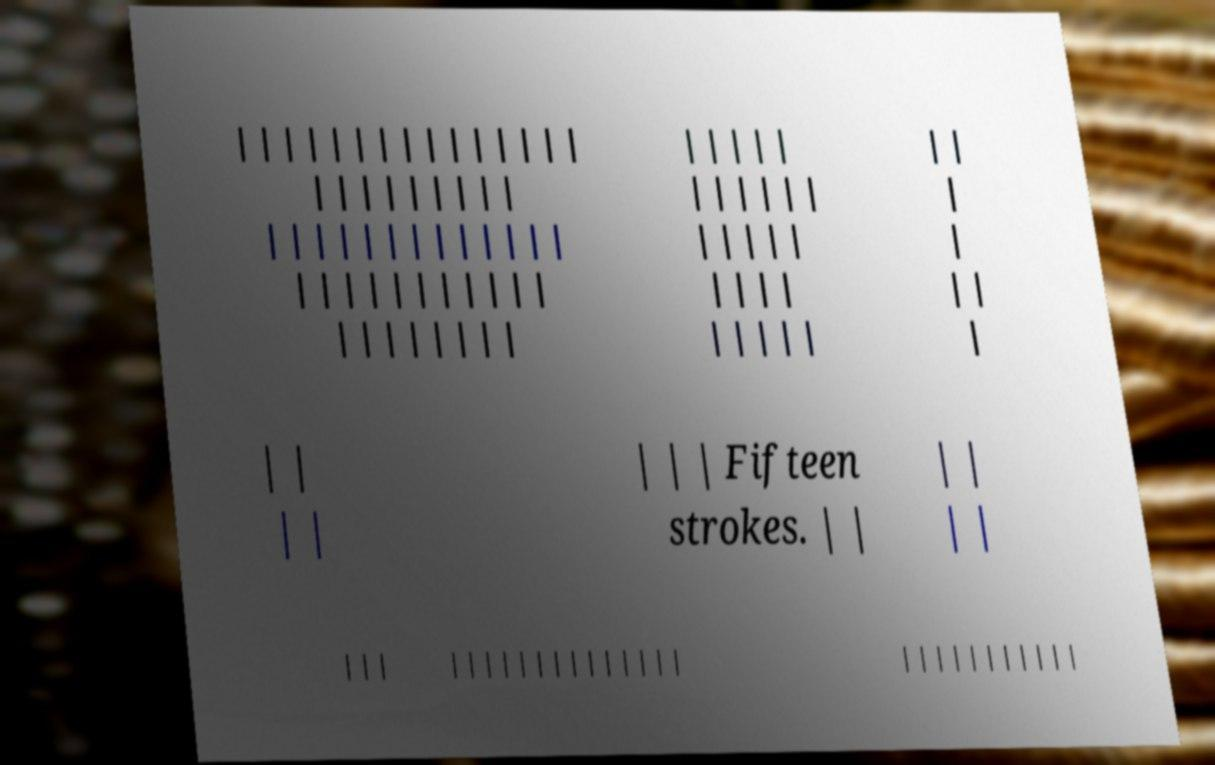Can you accurately transcribe the text from the provided image for me? | | | | | | | | | | | | | | | | | | | | | | | | | | | | | | | | | | | | | | | | | | | | | | | | | | | | | | | | | | | | | | | | | | | | | | | | | | | | | | | | | | | | | | | | | | | | | | | Fifteen strokes. | | | | | | | | | | | | | | | | | | | | | | | | | | | | | | | | | | 